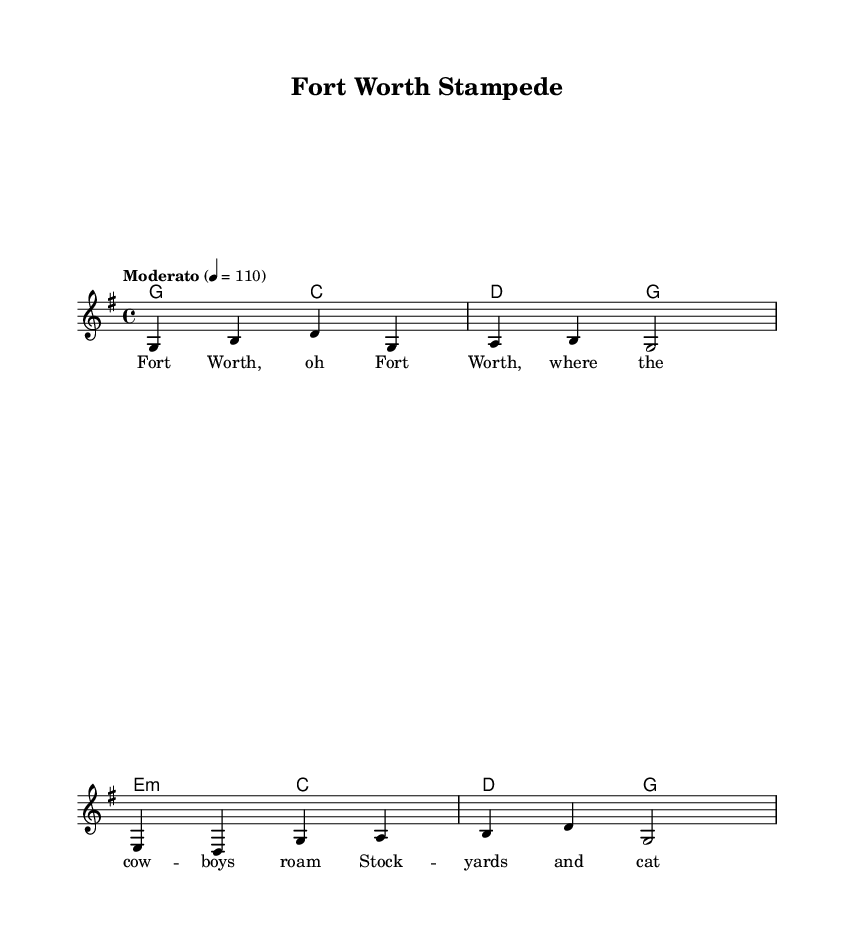What is the key signature of this music? The key signature is indicated by the first few measures and shows that there is one sharp (F#), which means this piece is in the key of G major.
Answer: G major What is the time signature of this piece? The time signature is shown at the beginning of the score as 4/4, which means there are four beats in each measure and the quarter note gets one beat.
Answer: 4/4 What is the tempo marking for the music? The tempo marking is located above the staff and indicates 'Moderato' with a metronome marking of 110 beats per minute, suggesting a moderate pace.
Answer: Moderato What are the first two notes of the melody? The melody begins with the notes G and B, as indicated in the first measure of the melody line.
Answer: G, B How many measures are there in the melody? By counting the measures as visually represented, the melody spans a total of four measures.
Answer: Four Which chord is introduced in measure 2? In measure 2, the chord indicated is a D major chord, which consists of the notes D, F#, and A, as represented in the harmonies.
Answer: D What theme is represented in the lyrics? The lyrics express a sense of pride and connection to Fort Worth's cowboy heritage, emphasizing key elements like cowboy culture and local pride.
Answer: Cowboy heritage 